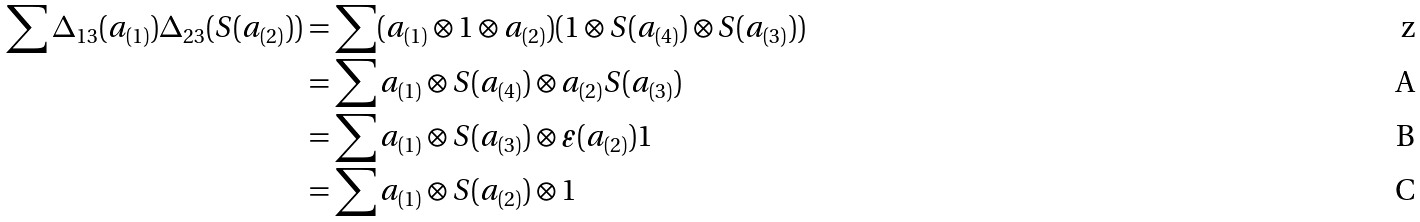<formula> <loc_0><loc_0><loc_500><loc_500>\sum \Delta _ { 1 3 } ( a _ { ( 1 ) } ) \Delta _ { 2 3 } ( S ( a _ { ( 2 ) } ) ) & = \sum ( a _ { ( 1 ) } \otimes 1 \otimes a _ { ( 2 ) } ) ( 1 \otimes S ( a _ { ( 4 ) } ) \otimes S ( a _ { ( 3 ) } ) ) \\ & = \sum a _ { ( 1 ) } \otimes S ( a _ { ( 4 ) } ) \otimes a _ { ( 2 ) } S ( a _ { ( 3 ) } ) \\ & = \sum a _ { ( 1 ) } \otimes S ( a _ { ( 3 ) } ) \otimes \varepsilon ( a _ { ( 2 ) } ) 1 \\ & = \sum a _ { ( 1 ) } \otimes S ( a _ { ( 2 ) } ) \otimes 1</formula> 